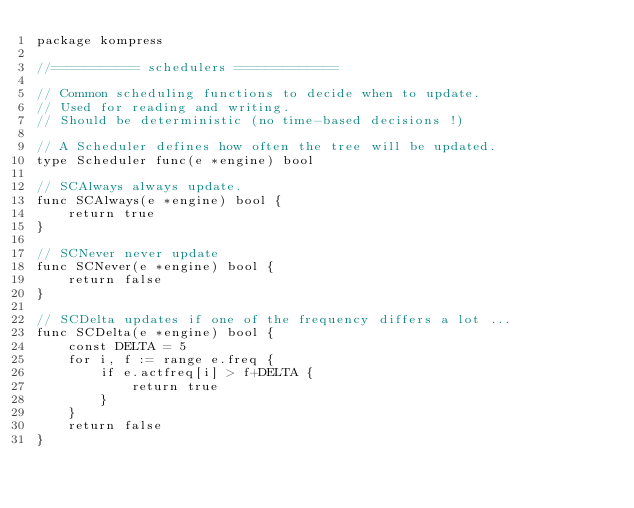Convert code to text. <code><loc_0><loc_0><loc_500><loc_500><_Go_>package kompress

//=========== schedulers =============

// Common scheduling functions to decide when to update.
// Used for reading and writing.
// Should be deterministic (no time-based decisions !)

// A Scheduler defines how often the tree will be updated.
type Scheduler func(e *engine) bool

// SCAlways always update.
func SCAlways(e *engine) bool {
	return true
}

// SCNever never update
func SCNever(e *engine) bool {
	return false
}

// SCDelta updates if one of the frequency differs a lot ...
func SCDelta(e *engine) bool {
	const DELTA = 5
	for i, f := range e.freq {
		if e.actfreq[i] > f+DELTA {
			return true
		}
	}
	return false
}
</code> 